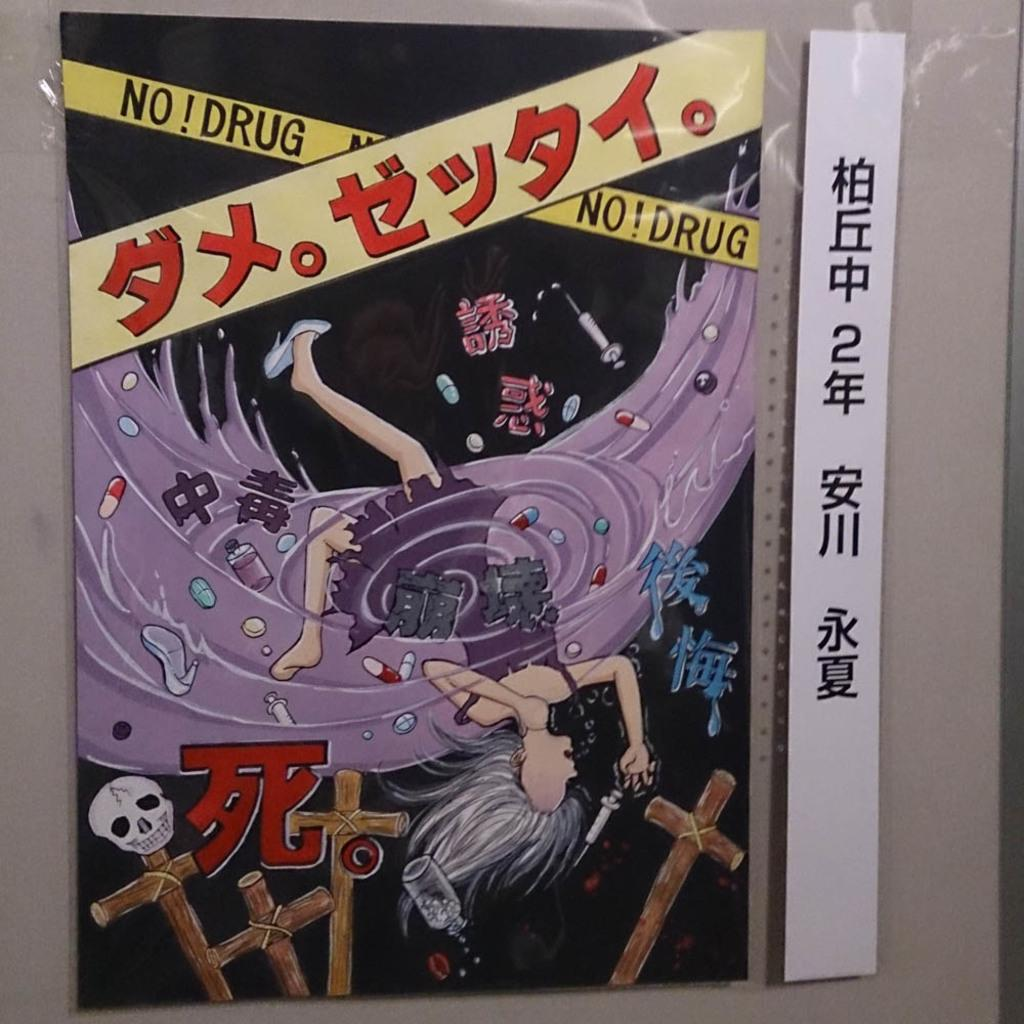<image>
Relay a brief, clear account of the picture shown. A picture of a girl in heels says no drug near the top. 